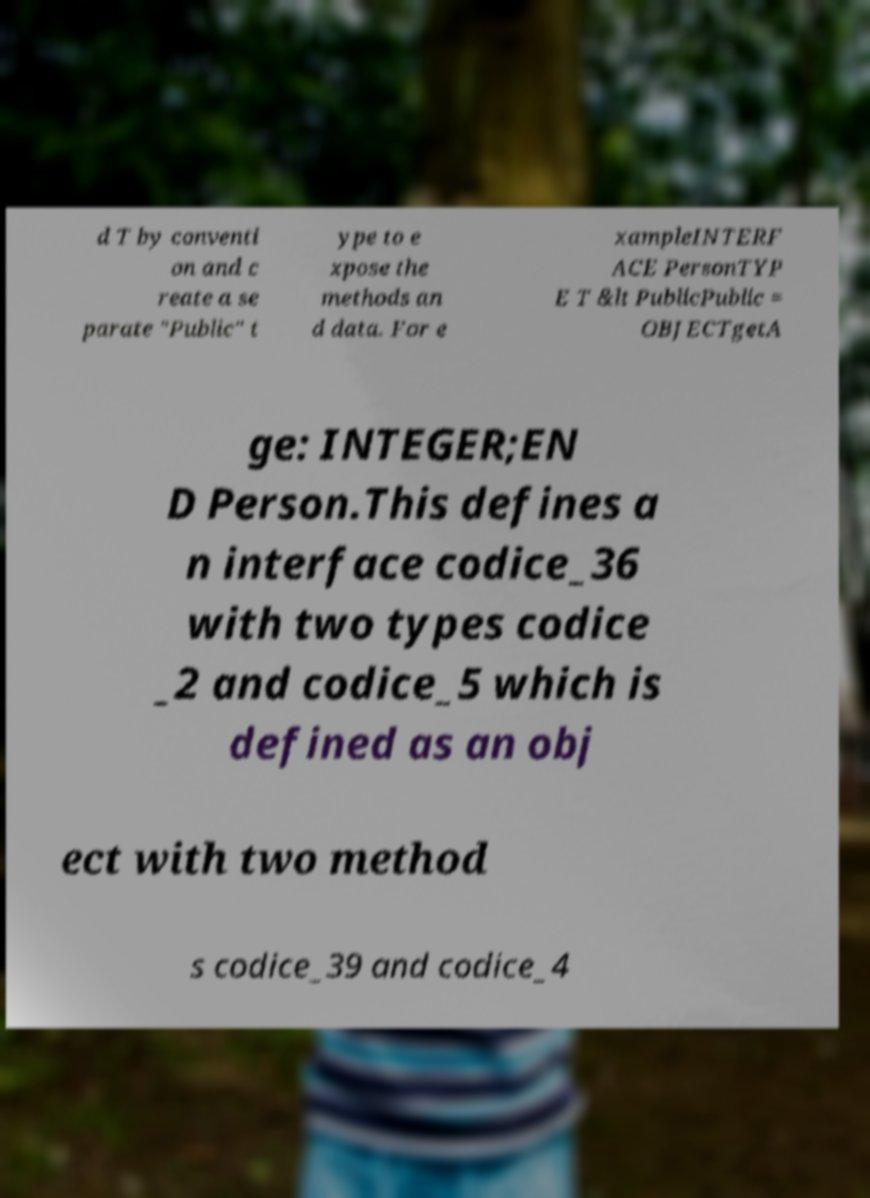Could you assist in decoding the text presented in this image and type it out clearly? d T by conventi on and c reate a se parate "Public" t ype to e xpose the methods an d data. For e xampleINTERF ACE PersonTYP E T &lt PublicPublic = OBJECTgetA ge: INTEGER;EN D Person.This defines a n interface codice_36 with two types codice _2 and codice_5 which is defined as an obj ect with two method s codice_39 and codice_4 